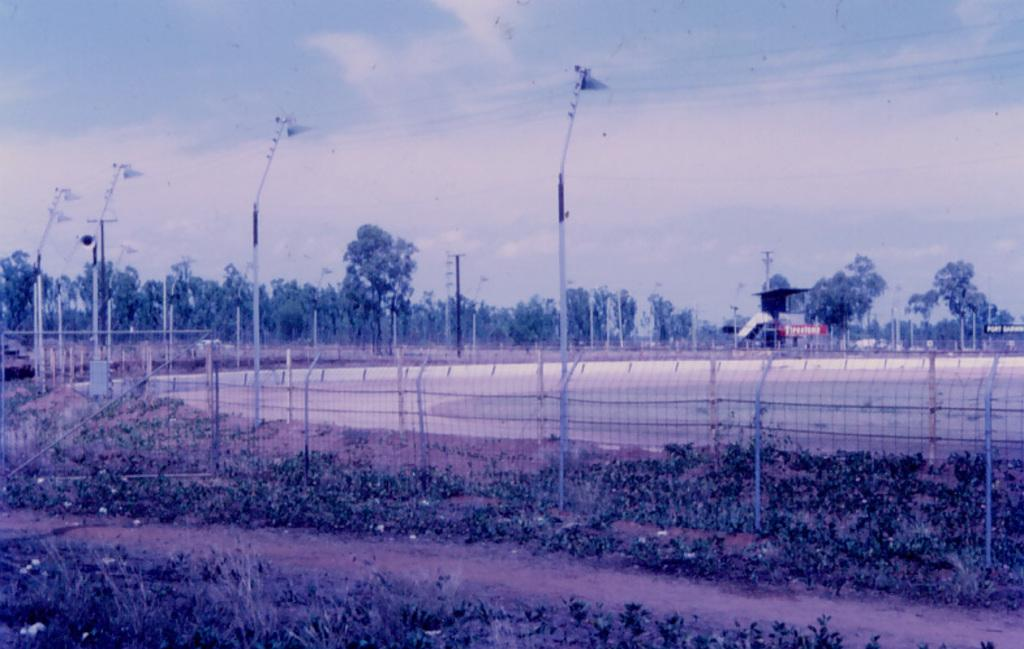What type of vegetation is present on the ground in the image? There are plants on the ground in the image. What type of barrier can be seen in the image? There is a fence in the image. What vertical structures are present in the image? There are poles in the image. What type of tall vegetation is present in the image? There are trees in the image. What other objects can be seen in the image? There are some objects in the image. What is visible in the background of the image? The sky is visible in the background of the image. What degree does the baby have in the image? There is no baby present in the image, so it is not possible to determine if any baby has a degree. What type of selection process is depicted in the image? There is no selection process depicted in the image. 